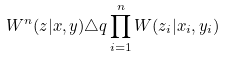Convert formula to latex. <formula><loc_0><loc_0><loc_500><loc_500>W ^ { n } ( z | x , y ) \triangle q \prod _ { i = 1 } ^ { n } W ( z _ { i } | x _ { i } , y _ { i } )</formula> 